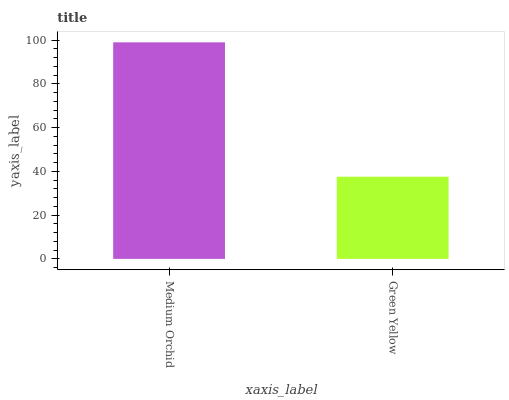Is Green Yellow the minimum?
Answer yes or no. Yes. Is Medium Orchid the maximum?
Answer yes or no. Yes. Is Green Yellow the maximum?
Answer yes or no. No. Is Medium Orchid greater than Green Yellow?
Answer yes or no. Yes. Is Green Yellow less than Medium Orchid?
Answer yes or no. Yes. Is Green Yellow greater than Medium Orchid?
Answer yes or no. No. Is Medium Orchid less than Green Yellow?
Answer yes or no. No. Is Medium Orchid the high median?
Answer yes or no. Yes. Is Green Yellow the low median?
Answer yes or no. Yes. Is Green Yellow the high median?
Answer yes or no. No. Is Medium Orchid the low median?
Answer yes or no. No. 